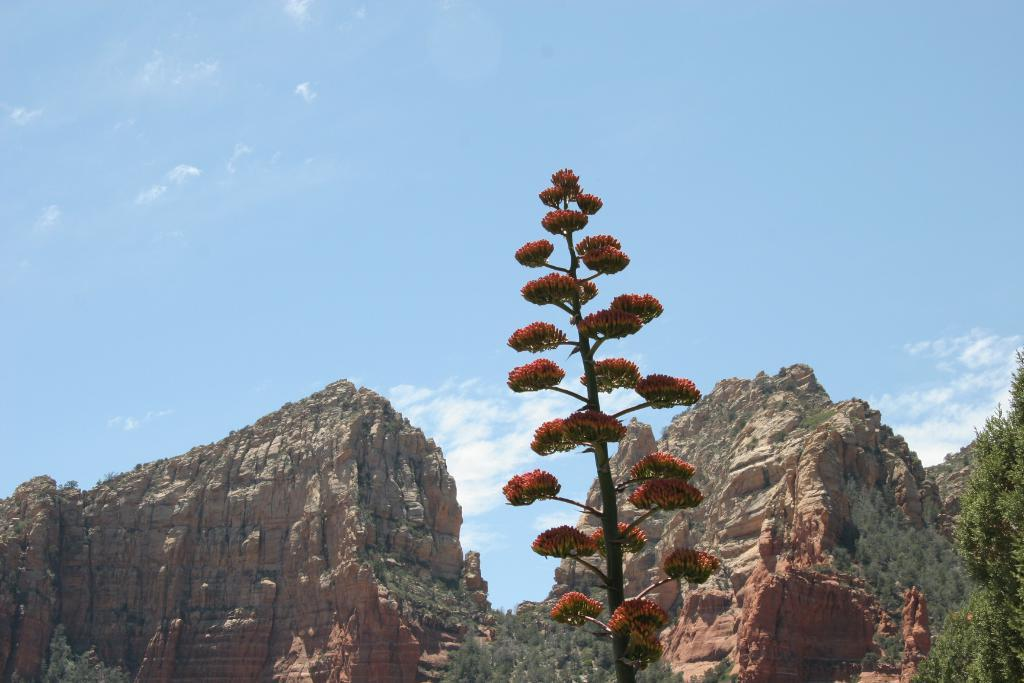What is the main subject in the center of the image? There is a plant in the center of the image. What can be seen in the distance behind the plant? There are mountains visible in the background of the image. What other type of vegetation is present in the image? There is a tree on the right side of the image. What type of leather is draped over the tree in the image? There is no leather present in the image; it features a plant, mountains, and a tree. 